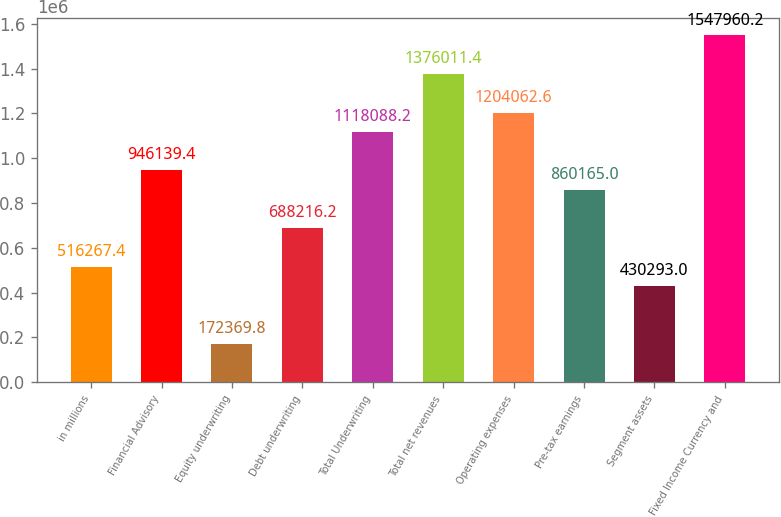Convert chart to OTSL. <chart><loc_0><loc_0><loc_500><loc_500><bar_chart><fcel>in millions<fcel>Financial Advisory<fcel>Equity underwriting<fcel>Debt underwriting<fcel>Total Underwriting<fcel>Total net revenues<fcel>Operating expenses<fcel>Pre-tax earnings<fcel>Segment assets<fcel>Fixed Income Currency and<nl><fcel>516267<fcel>946139<fcel>172370<fcel>688216<fcel>1.11809e+06<fcel>1.37601e+06<fcel>1.20406e+06<fcel>860165<fcel>430293<fcel>1.54796e+06<nl></chart> 